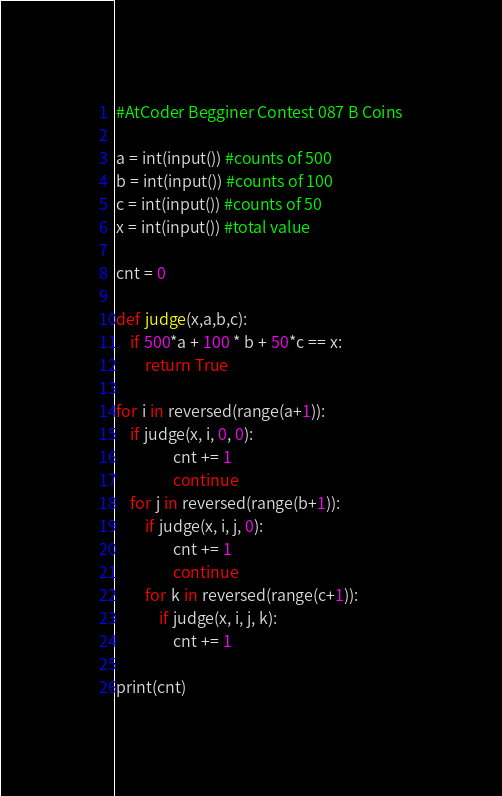Convert code to text. <code><loc_0><loc_0><loc_500><loc_500><_Python_>#AtCoder Begginer Contest 087 B Coins

a = int(input()) #counts of 500
b = int(input()) #counts of 100
c = int(input()) #counts of 50
x = int(input()) #total value

cnt = 0

def judge(x,a,b,c):
    if 500*a + 100 * b + 50*c == x:
        return True
    
for i in reversed(range(a+1)):
    if judge(x, i, 0, 0):
                cnt += 1
                continue
    for j in reversed(range(b+1)):
        if judge(x, i, j, 0):
                cnt += 1
                continue
        for k in reversed(range(c+1)):
            if judge(x, i, j, k):
                cnt += 1

print(cnt)





</code> 